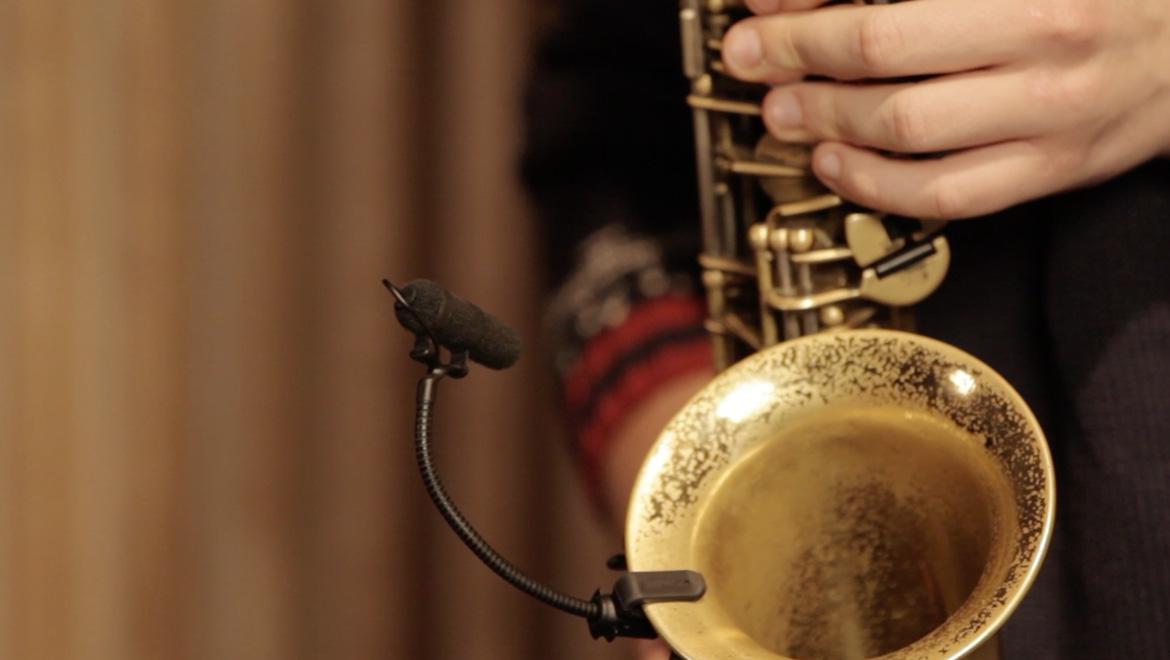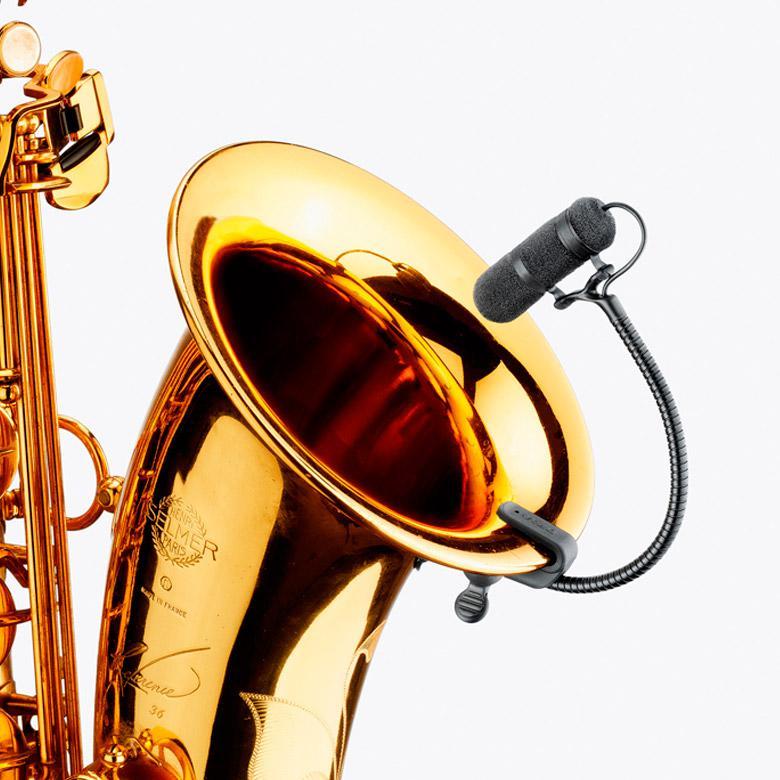The first image is the image on the left, the second image is the image on the right. For the images shown, is this caption "At least one image includes a rightward turned man in dark clothing standing and playing a saxophone." true? Answer yes or no. No. The first image is the image on the left, the second image is the image on the right. For the images displayed, is the sentence "A man is blowing into the mouthpiece of the saxophone." factually correct? Answer yes or no. No. 